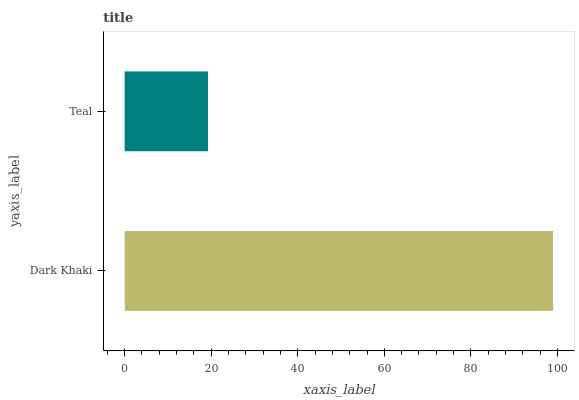Is Teal the minimum?
Answer yes or no. Yes. Is Dark Khaki the maximum?
Answer yes or no. Yes. Is Teal the maximum?
Answer yes or no. No. Is Dark Khaki greater than Teal?
Answer yes or no. Yes. Is Teal less than Dark Khaki?
Answer yes or no. Yes. Is Teal greater than Dark Khaki?
Answer yes or no. No. Is Dark Khaki less than Teal?
Answer yes or no. No. Is Dark Khaki the high median?
Answer yes or no. Yes. Is Teal the low median?
Answer yes or no. Yes. Is Teal the high median?
Answer yes or no. No. Is Dark Khaki the low median?
Answer yes or no. No. 